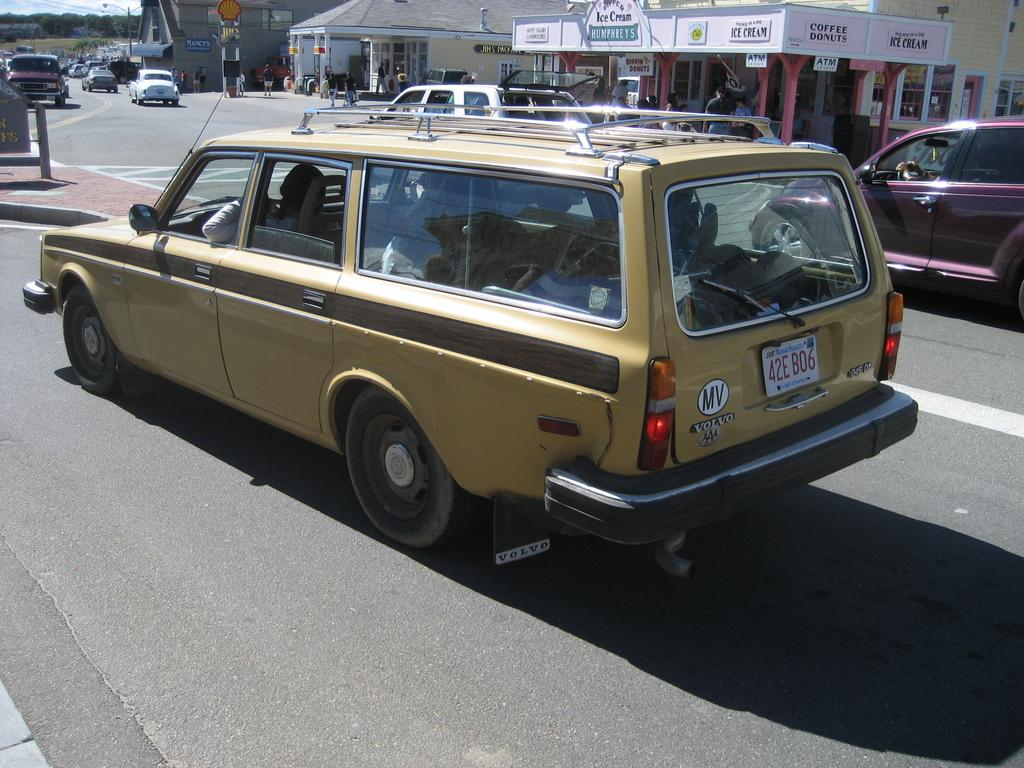What is happening on the road in the image? There are cars moving on the road in the image. What can be seen on the side of the road? There are buildings visible on the side of the road. What type of vegetation is present in the image? There are trees in the image. What is providing light in the image? There is a pole light in the image. What type of brass instrument is being played in the scene? There is no brass instrument or scene present in the image; it features cars moving on the road, buildings, trees, and a pole light. Can you see a basketball court in the image? There is no basketball court visible in the image. 